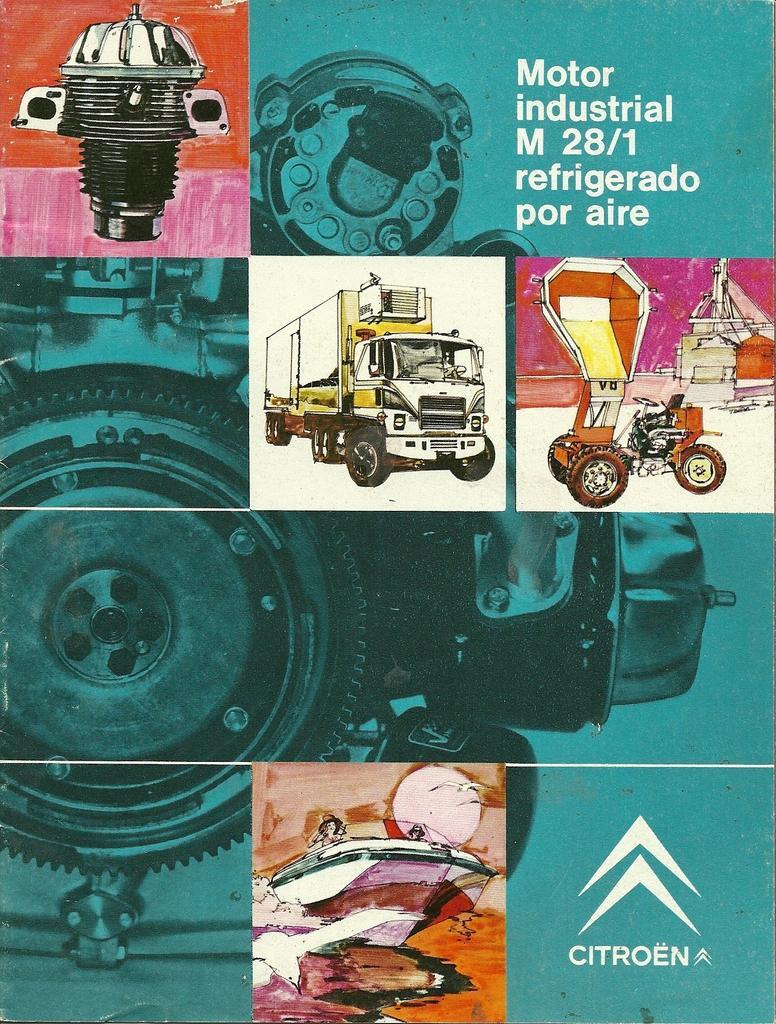Describe this image in one or two sentences. This picture describes about cover page, and we can find few paintings. 